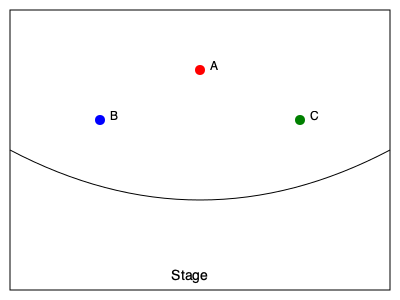As an actress familiar with various theater layouts, which seat in this simplified thrust stage floor plan would likely offer the best view of the entire performance area? To determine the best seat for viewing the entire performance area in a thrust stage theater, we need to consider the following factors:

1. Thrust stage layout: The stage extends into the audience area, with spectators on three sides.

2. Viewing angles:
   - Seat A is centrally located but farther from the stage.
   - Seats B and C are closer to the stage but on the sides.

3. Field of view:
   - Seat A offers a wide, symmetrical view of the entire stage.
   - Seats B and C provide closer views but may have partially obstructed sightlines to the opposite side of the stage.

4. Distance from the stage:
   - While seats B and C are closer, their angled position might limit visibility of some stage areas.
   - Seat A, though farther, has an unobstructed view of the entire stage.

5. Actor movements:
   - Thrust stages often have actors moving in all directions, making a central view advantageous.

6. Set design considerations:
   - Sets on thrust stages are usually minimal and designed to be viewed from all angles, favoring a central position.

Given these factors, Seat A would likely offer the best overall view of the entire performance area, as it provides a balanced, unobstructed view of the stage from a central position.
Answer: Seat A 